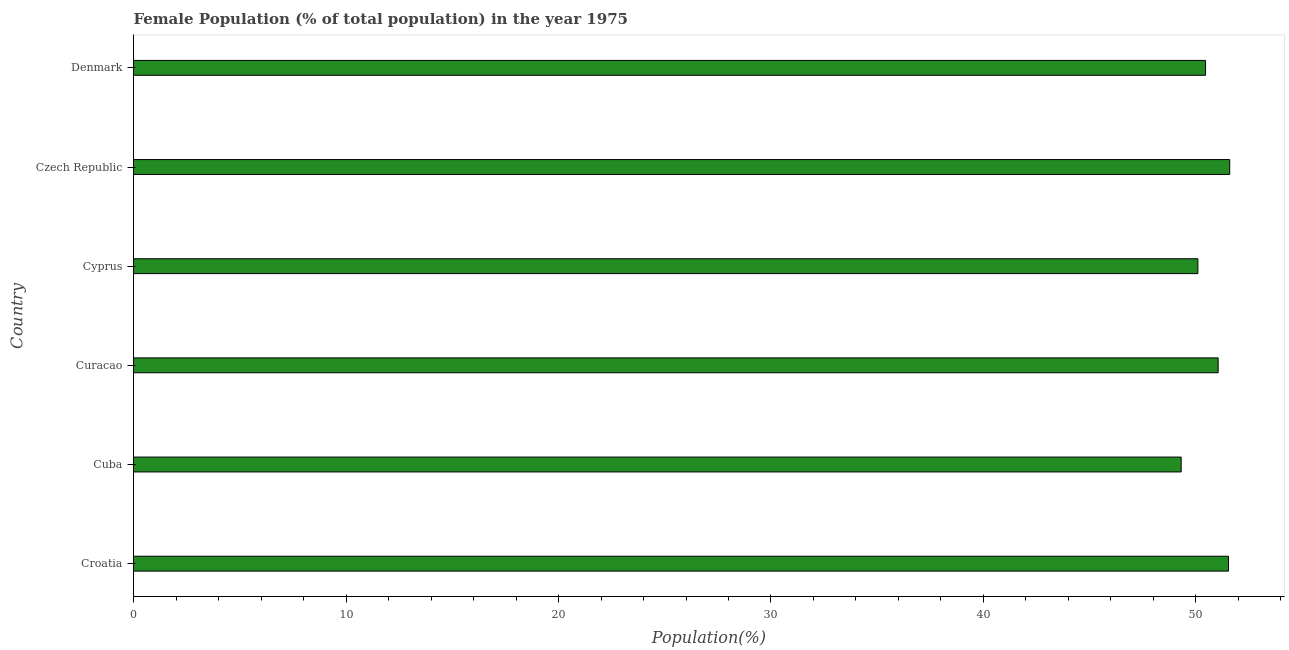Does the graph contain any zero values?
Give a very brief answer. No. Does the graph contain grids?
Provide a short and direct response. No. What is the title of the graph?
Offer a very short reply. Female Population (% of total population) in the year 1975. What is the label or title of the X-axis?
Your answer should be very brief. Population(%). What is the label or title of the Y-axis?
Give a very brief answer. Country. What is the female population in Curacao?
Offer a terse response. 51.04. Across all countries, what is the maximum female population?
Keep it short and to the point. 51.59. Across all countries, what is the minimum female population?
Provide a succinct answer. 49.3. In which country was the female population maximum?
Make the answer very short. Czech Republic. In which country was the female population minimum?
Your answer should be very brief. Cuba. What is the sum of the female population?
Your answer should be very brief. 304. What is the difference between the female population in Cuba and Czech Republic?
Give a very brief answer. -2.28. What is the average female population per country?
Provide a succinct answer. 50.67. What is the median female population?
Your answer should be compact. 50.75. In how many countries, is the female population greater than 52 %?
Your answer should be compact. 0. Is the female population in Croatia less than that in Cuba?
Provide a short and direct response. No. Is the difference between the female population in Curacao and Czech Republic greater than the difference between any two countries?
Your answer should be very brief. No. What is the difference between the highest and the second highest female population?
Your answer should be compact. 0.06. What is the difference between the highest and the lowest female population?
Keep it short and to the point. 2.28. Are all the bars in the graph horizontal?
Ensure brevity in your answer.  Yes. How many countries are there in the graph?
Make the answer very short. 6. Are the values on the major ticks of X-axis written in scientific E-notation?
Your answer should be very brief. No. What is the Population(%) of Croatia?
Give a very brief answer. 51.53. What is the Population(%) of Cuba?
Offer a very short reply. 49.3. What is the Population(%) of Curacao?
Provide a succinct answer. 51.04. What is the Population(%) of Cyprus?
Your answer should be very brief. 50.09. What is the Population(%) of Czech Republic?
Provide a short and direct response. 51.59. What is the Population(%) of Denmark?
Your answer should be very brief. 50.45. What is the difference between the Population(%) in Croatia and Cuba?
Your answer should be very brief. 2.23. What is the difference between the Population(%) in Croatia and Curacao?
Offer a terse response. 0.49. What is the difference between the Population(%) in Croatia and Cyprus?
Provide a short and direct response. 1.44. What is the difference between the Population(%) in Croatia and Czech Republic?
Give a very brief answer. -0.06. What is the difference between the Population(%) in Croatia and Denmark?
Offer a very short reply. 1.08. What is the difference between the Population(%) in Cuba and Curacao?
Offer a terse response. -1.74. What is the difference between the Population(%) in Cuba and Cyprus?
Your response must be concise. -0.79. What is the difference between the Population(%) in Cuba and Czech Republic?
Offer a very short reply. -2.28. What is the difference between the Population(%) in Cuba and Denmark?
Your answer should be very brief. -1.15. What is the difference between the Population(%) in Curacao and Cyprus?
Your response must be concise. 0.95. What is the difference between the Population(%) in Curacao and Czech Republic?
Make the answer very short. -0.54. What is the difference between the Population(%) in Curacao and Denmark?
Provide a succinct answer. 0.59. What is the difference between the Population(%) in Cyprus and Czech Republic?
Keep it short and to the point. -1.5. What is the difference between the Population(%) in Cyprus and Denmark?
Offer a terse response. -0.36. What is the difference between the Population(%) in Czech Republic and Denmark?
Provide a succinct answer. 1.14. What is the ratio of the Population(%) in Croatia to that in Cuba?
Provide a succinct answer. 1.04. What is the ratio of the Population(%) in Croatia to that in Czech Republic?
Provide a short and direct response. 1. What is the ratio of the Population(%) in Cuba to that in Curacao?
Offer a terse response. 0.97. What is the ratio of the Population(%) in Cuba to that in Czech Republic?
Make the answer very short. 0.96. What is the ratio of the Population(%) in Curacao to that in Cyprus?
Offer a very short reply. 1.02. What is the ratio of the Population(%) in Curacao to that in Czech Republic?
Keep it short and to the point. 0.99. What is the ratio of the Population(%) in Cyprus to that in Czech Republic?
Make the answer very short. 0.97. What is the ratio of the Population(%) in Cyprus to that in Denmark?
Give a very brief answer. 0.99. What is the ratio of the Population(%) in Czech Republic to that in Denmark?
Provide a short and direct response. 1.02. 